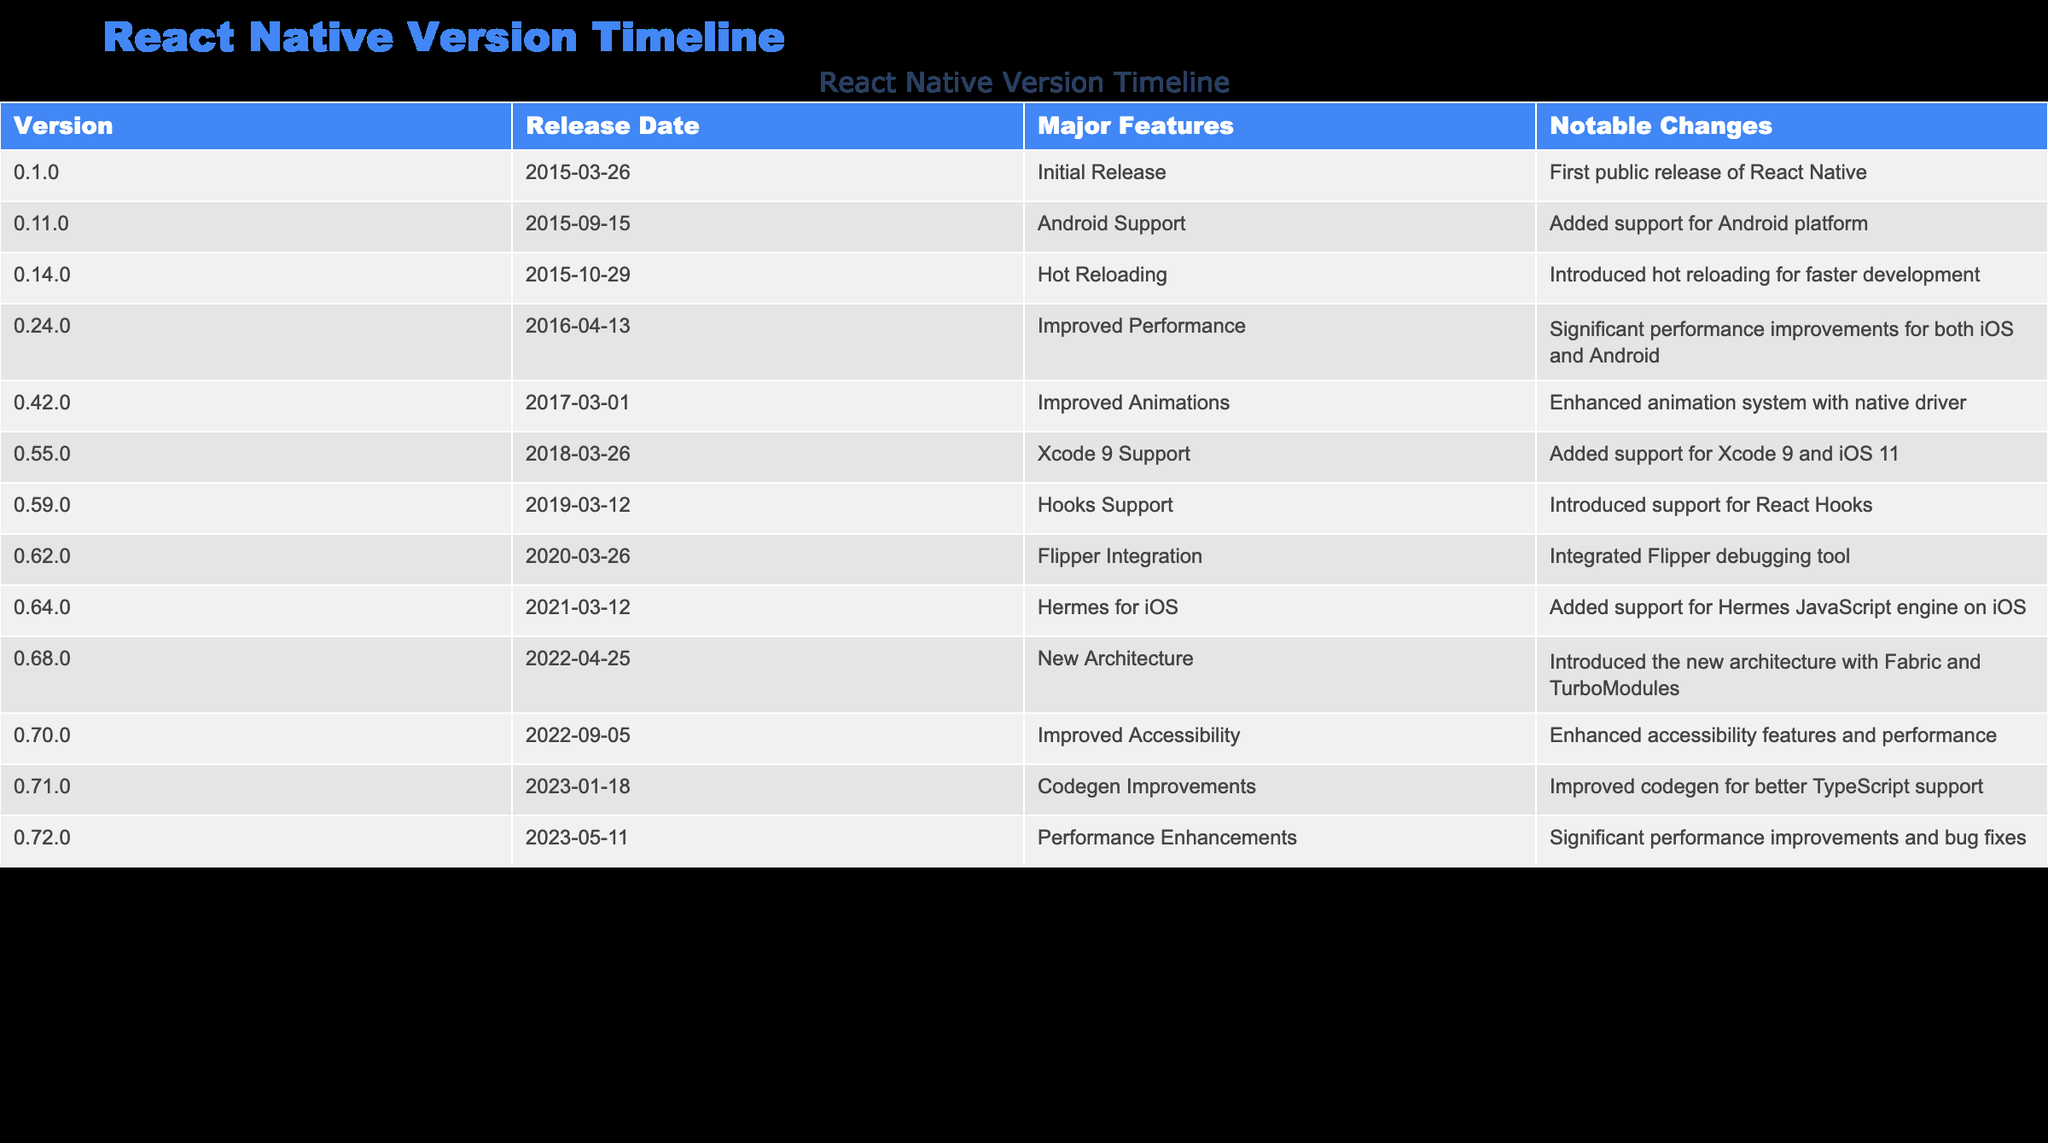What is the release date of version 0.55.0? The table lists the release date of version 0.55.0, which is explicitly provided as March 26, 2018.
Answer: March 26, 2018 What major feature was introduced in version 0.62.0? According to the table, the major feature introduced in version 0.62.0 is Flipper Integration. This is directly stated in the "Major Features" column for that version.
Answer: Flipper Integration How many versions were released between 2016 and 2020? By examining the release dates in the table, I can identify the versions released in that timeframe: 0.24.0 (2016), 0.42.0 (2017), 0.55.0 (2018), 0.59.0 (2019), and 0.62.0 (2020). Counting these versions, there are 5 in total.
Answer: 5 Is there a version that introduced support for the Hermes JavaScript engine? The table indicates that version 0.64.0 introduced support for the Hermes JavaScript engine on iOS, making this statement true.
Answer: Yes What is the difference in release dates between version 0.70.0 and version 0.72.0? Version 0.70.0 was released on September 5, 2022, and version 0.72.0 was released on May 11, 2023. To find the difference, I can find the number of days from September 5, 2022, to May 11, 2023, which is approximately 8 months or around 220 days, confirming a significant interval between the two releases.
Answer: Approximately 220 days Which version had the notable change of "Improved Accessibility"? According to the table, version 0.70.0 is noted for having the change of "Improved Accessibility." This is listed in the "Notable Changes" column corresponding to that version.
Answer: 0.70.0 What were the major features listed for versions from 2019? In 2019, the version 0.59.0 introduced "Hooks Support," which is clearly stated in the "Major Features" column for that specific version. Thus, the major feature for that year is Hooks Support.
Answer: Hooks Support Which version had significant performance improvements after version 0.24.0, and what were the notable changes? The table shows that version 0.55.0 released on March 26, 2018, had the notable change of "Xcode 9 Support" and preceded version 0.62.0 that also noted "Flipper Integration." Thus, I see that version 0.55.0 had significant updates related to that timeline.
Answer: Version 0.55.0, Xcode 9 Support How many versions introduced improvements to performance? By checking the significant updates in the "Major Features" column, I see that versions 0.24.0 (Improved Performance), 0.72.0 (Performance Enhancements), and 0.70.0 (Improved Accessibility) had noteworthy updates regarding performance. Summing these, it's evident there are 3 versions focusing on performance improvements.
Answer: 3 